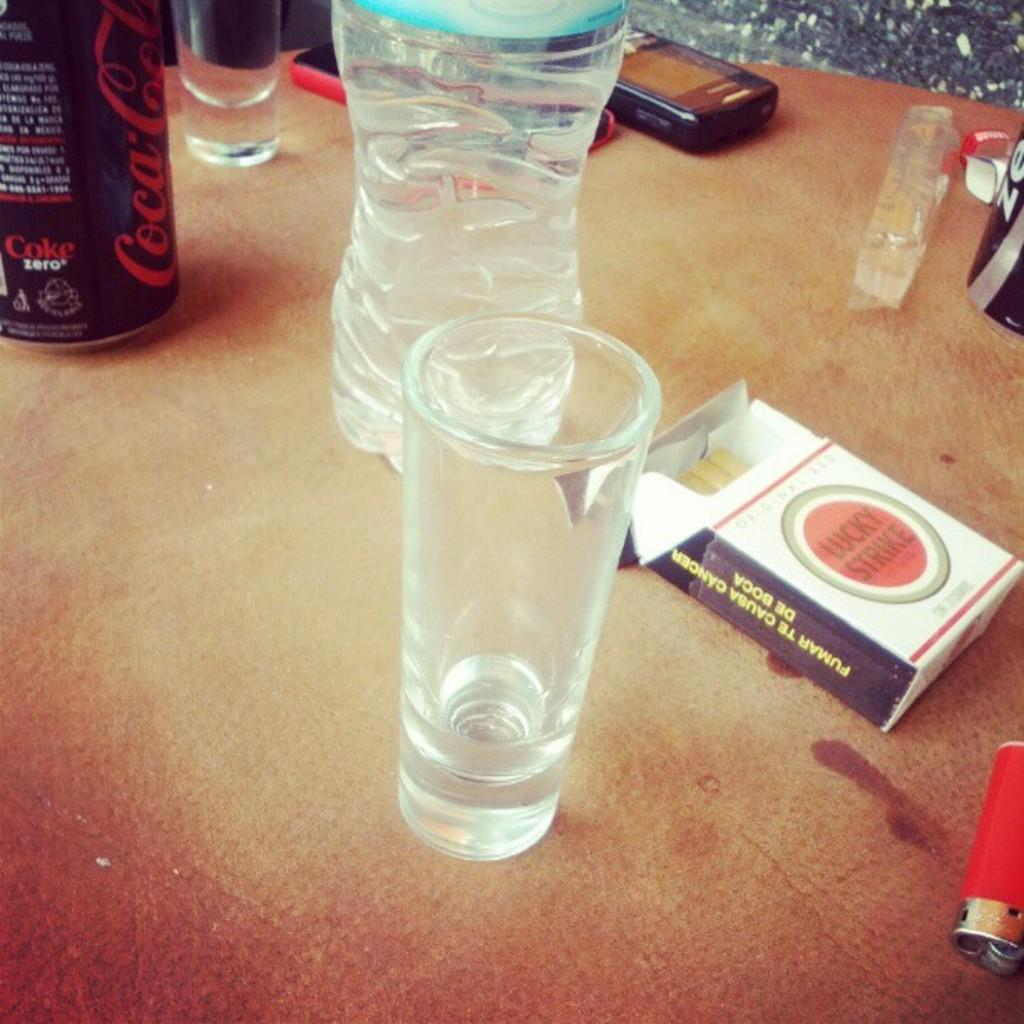What type of furniture is present in the image? There is a table in the image. What items can be seen on the table? There are glasses, a bottle, a can, a cigarette box, and a lighter on the table. Are there any other objects on the table? Yes, there are other objects on the table. How many planes are flying over the table in the image? There are no planes visible in the image; it only shows a table with various objects on it. 